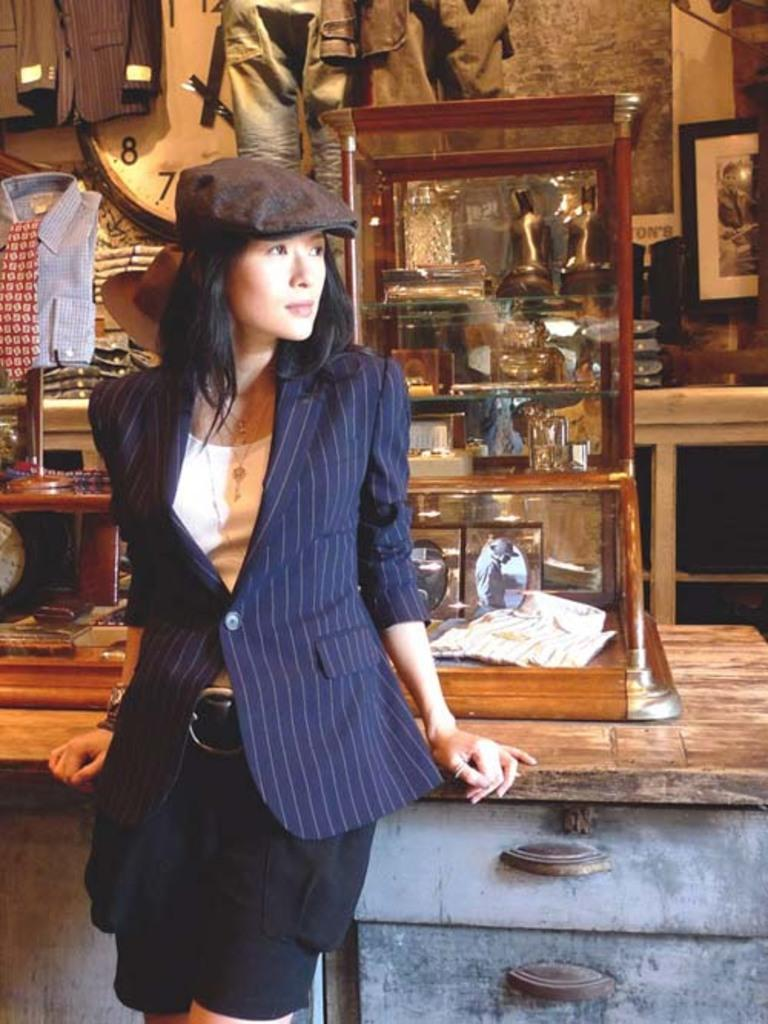What is the main subject in the image? There is a person in the image. What object can be seen in the background? There is a clock in the image. What type of items are visible in the image? There are clothes and photos in the image. Can you describe any other objects in the image? There are other objects in the image, but their specific details are not mentioned in the provided facts. What type of transport is the person using in the image? There is no indication of any transport in the image, as it only shows a person, a clock, clothes, and photos. 